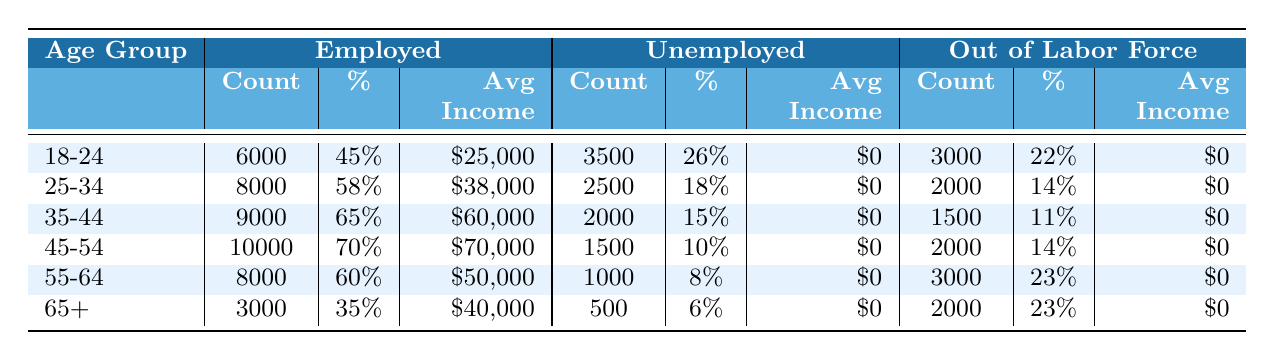What is the percentage of employed individuals in the age group 25-34? In the table, under the age group 25-34, the percentage of employed individuals is listed as 58%.
Answer: 58% Which age group has the highest average income? The highest average income is found in the age group 45-54, with an average income of $70,000.
Answer: 45-54 What is the total number of unemployed individuals across all age groups? By adding up the counts of unemployed individuals from each age group: 3500 (18-24) + 2500 (25-34) + 2000 (35-44) + 1500 (45-54) + 1000 (55-64) + 500 (65+) =  12,000.
Answer: 12000 Is the percentage of individuals out of the labor force in the age group 55-64 greater than those in the age group 18-24? The percentage of individuals out of the labor force in 55-64 is 23%, while it is 22% in 18-24; thus, it is greater.
Answer: Yes What is the difference in the average income between the age groups 35-44 and 55-64? The average income for 35-44 is $60,000, and for 55-64 it is $50,000. The difference is $60,000 - $50,000 = $10,000.
Answer: $10,000 How many individuals aged 45-54 are out of the labor force? The count of individuals aged 45-54 who are out of the labor force is listed as 2000.
Answer: 2000 What percentage of the 65+ age group is unemployed? For the 65+ age group, the count of unemployed individuals is 500, which makes up 6% of that age group.
Answer: 6% Which age group has the least number of employed individuals? The age group with the least number of employed individuals is 65+, with a count of 3000.
Answer: 65+ Are there more part-time employees in the age group 18-24 or 25-34? In the age group 18-24, there are 1500 part-time employees, while in 25-34 there are 2500; thus, there are more in 25-34.
Answer: 25-34 What is the average income for part-time workers in the 45-54 age group? The average income for part-time workers in the 45-54 age group is $30,000, as indicated in the table.
Answer: $30,000 